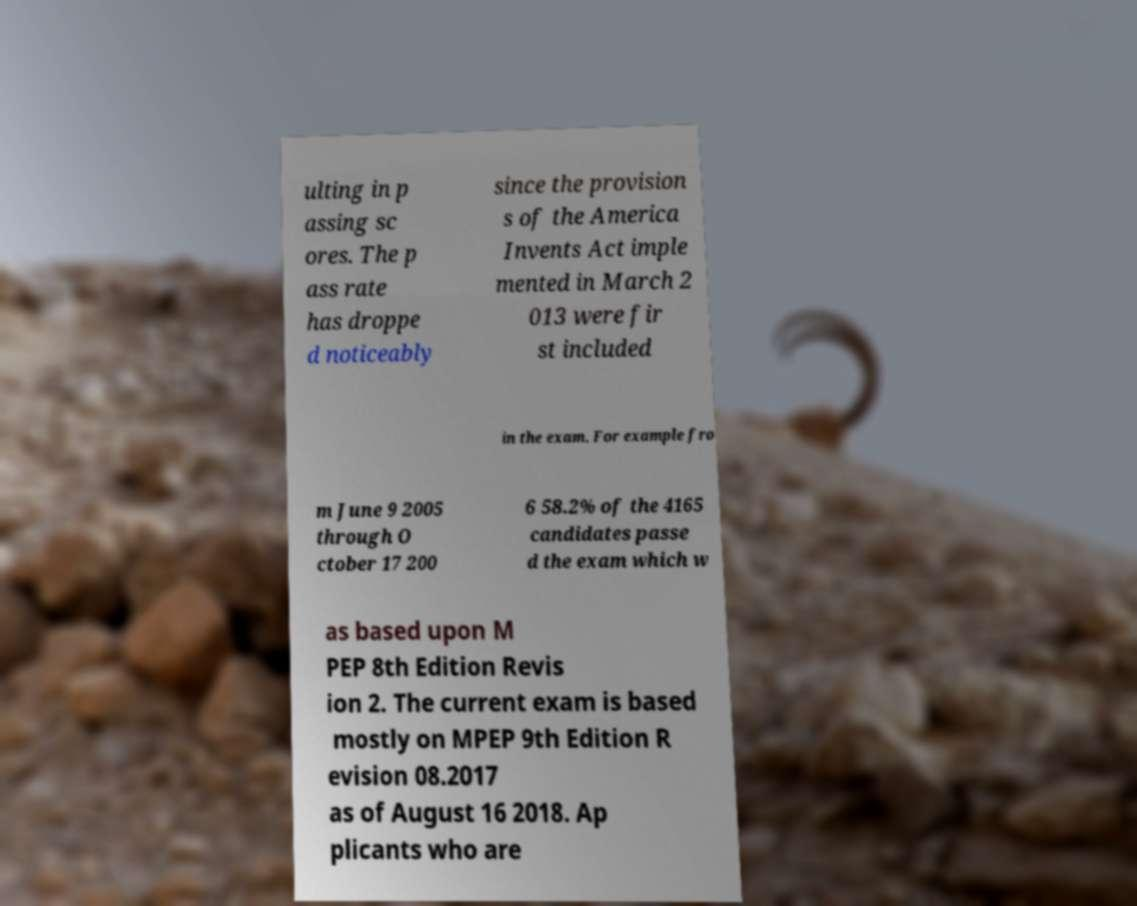What messages or text are displayed in this image? I need them in a readable, typed format. ulting in p assing sc ores. The p ass rate has droppe d noticeably since the provision s of the America Invents Act imple mented in March 2 013 were fir st included in the exam. For example fro m June 9 2005 through O ctober 17 200 6 58.2% of the 4165 candidates passe d the exam which w as based upon M PEP 8th Edition Revis ion 2. The current exam is based mostly on MPEP 9th Edition R evision 08.2017 as of August 16 2018. Ap plicants who are 